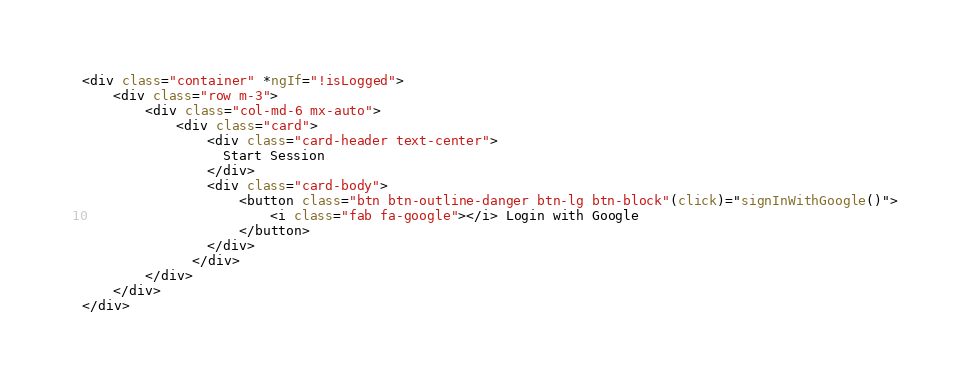Convert code to text. <code><loc_0><loc_0><loc_500><loc_500><_HTML_><div class="container" *ngIf="!isLogged">
    <div class="row m-3">
        <div class="col-md-6 mx-auto">
            <div class="card">
                <div class="card-header text-center">
                  Start Session
                </div>
                <div class="card-body">
                    <button class="btn btn-outline-danger btn-lg btn-block"(click)="signInWithGoogle()">
                        <i class="fab fa-google"></i> Login with Google
                    </button>
                </div>
              </div>
        </div>
    </div>
</div>

</code> 